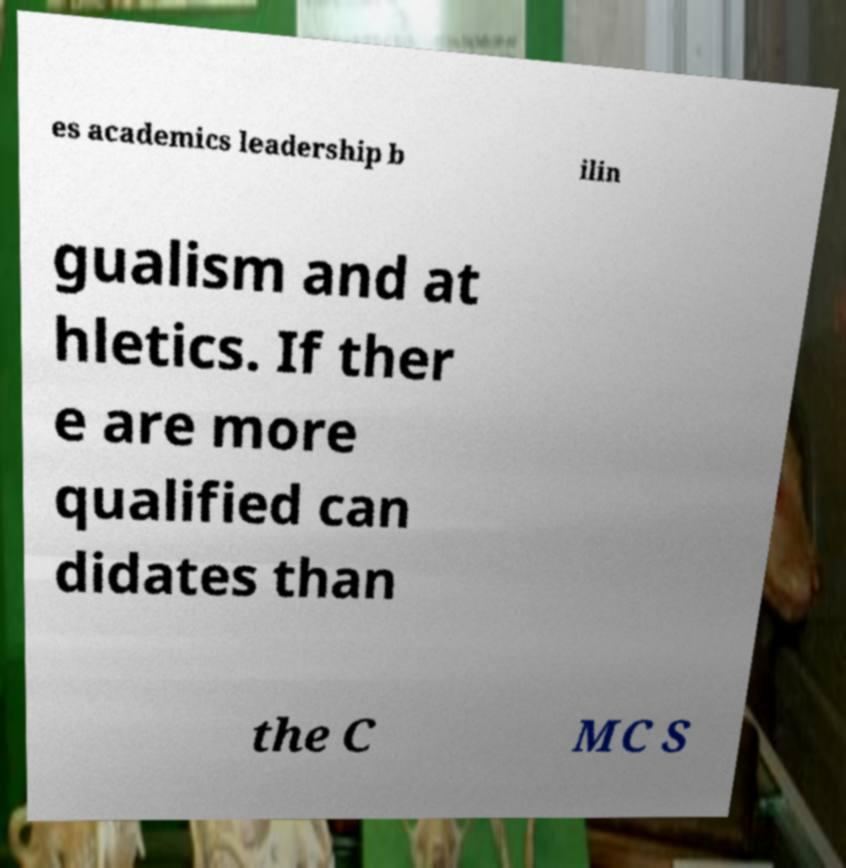Can you accurately transcribe the text from the provided image for me? es academics leadership b ilin gualism and at hletics. If ther e are more qualified can didates than the C MC S 